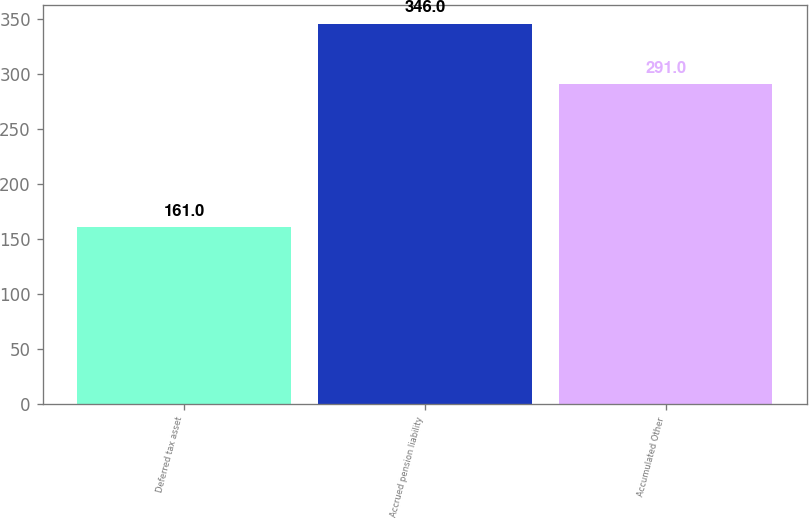<chart> <loc_0><loc_0><loc_500><loc_500><bar_chart><fcel>Deferred tax asset<fcel>Accrued pension liability<fcel>Accumulated Other<nl><fcel>161<fcel>346<fcel>291<nl></chart> 